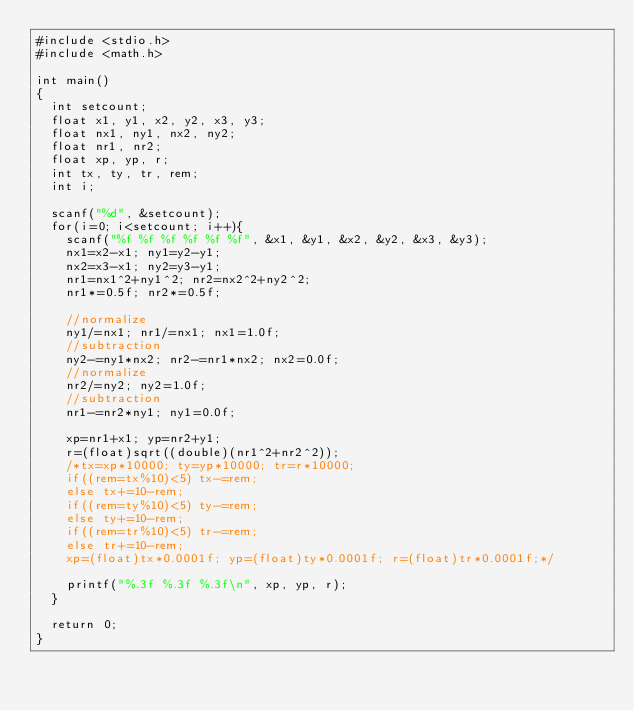Convert code to text. <code><loc_0><loc_0><loc_500><loc_500><_C_>#include <stdio.h>
#include <math.h>

int main()
{
  int setcount;
  float x1, y1, x2, y2, x3, y3;
  float nx1, ny1, nx2, ny2;
  float nr1, nr2;
  float xp, yp, r;
  int tx, ty, tr, rem;
  int i;

  scanf("%d", &setcount);
  for(i=0; i<setcount; i++){
    scanf("%f %f %f %f %f %f", &x1, &y1, &x2, &y2, &x3, &y3);
    nx1=x2-x1; ny1=y2-y1;
    nx2=x3-x1; ny2=y3-y1;
    nr1=nx1^2+ny1^2; nr2=nx2^2+ny2^2;
    nr1*=0.5f; nr2*=0.5f;

    //normalize
    ny1/=nx1; nr1/=nx1; nx1=1.0f;
    //subtraction
    ny2-=ny1*nx2; nr2-=nr1*nx2; nx2=0.0f;
    //normalize
    nr2/=ny2; ny2=1.0f;
    //subtraction
    nr1-=nr2*ny1; ny1=0.0f;

    xp=nr1+x1; yp=nr2+y1;
    r=(float)sqrt((double)(nr1^2+nr2^2));
    /*tx=xp*10000; ty=yp*10000; tr=r*10000;
    if((rem=tx%10)<5) tx-=rem;
    else tx+=10-rem;
    if((rem=ty%10)<5) ty-=rem;
    else ty+=10-rem;
    if((rem=tr%10)<5) tr-=rem;
    else tr+=10-rem;
    xp=(float)tx*0.0001f; yp=(float)ty*0.0001f; r=(float)tr*0.0001f;*/

    printf("%.3f %.3f %.3f\n", xp, yp, r);
  }

  return 0;
}</code> 